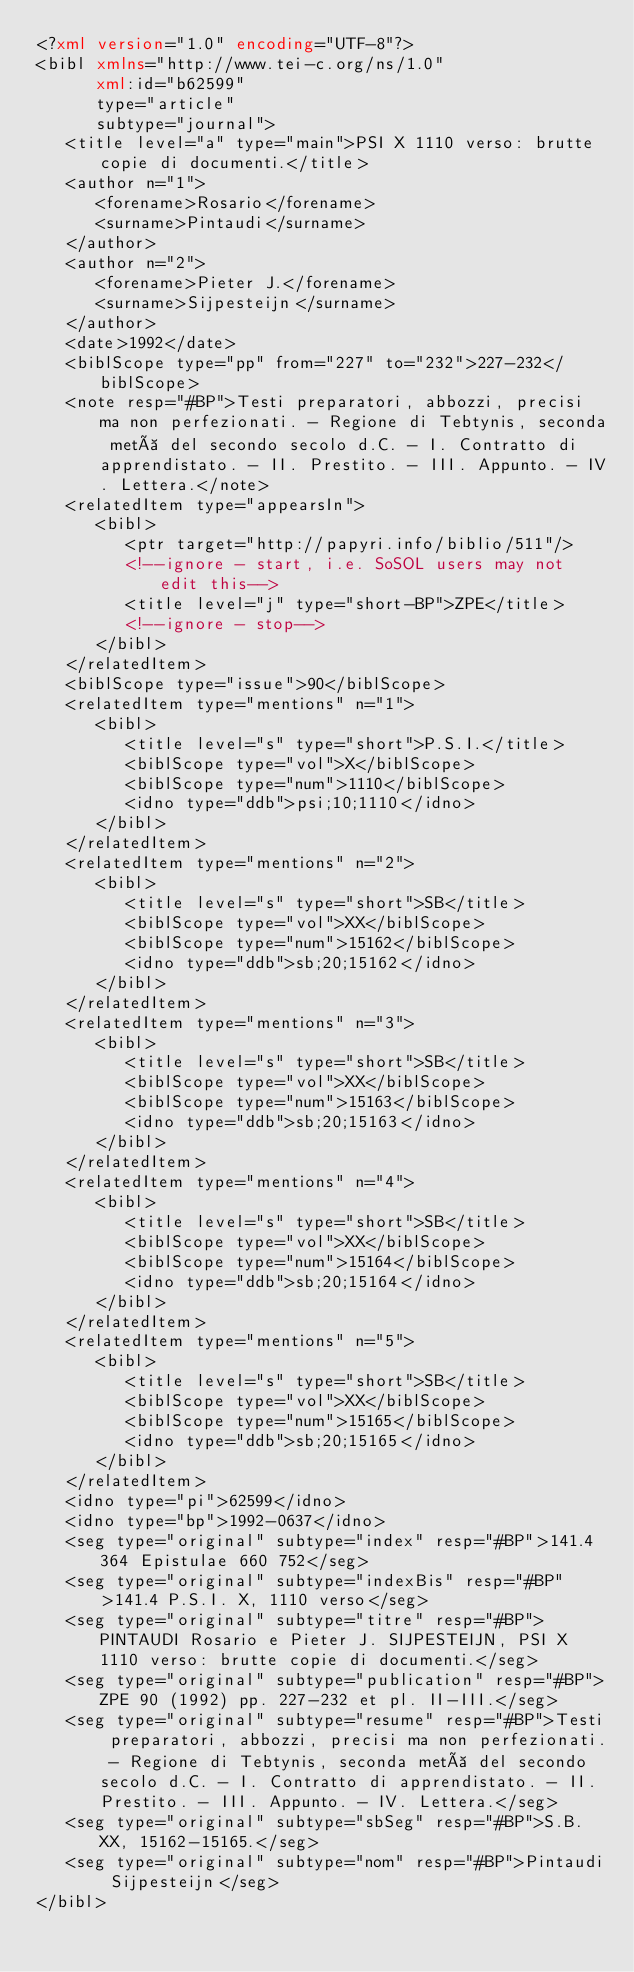<code> <loc_0><loc_0><loc_500><loc_500><_XML_><?xml version="1.0" encoding="UTF-8"?>
<bibl xmlns="http://www.tei-c.org/ns/1.0"
      xml:id="b62599"
      type="article"
      subtype="journal">
   <title level="a" type="main">PSI X 1110 verso: brutte copie di documenti.</title>
   <author n="1">
      <forename>Rosario</forename>
      <surname>Pintaudi</surname>
   </author>
   <author n="2">
      <forename>Pieter J.</forename>
      <surname>Sijpesteijn</surname>
   </author>
   <date>1992</date>
   <biblScope type="pp" from="227" to="232">227-232</biblScope>
   <note resp="#BP">Testi preparatori, abbozzi, precisi ma non perfezionati. - Regione di Tebtynis, seconda metà del secondo secolo d.C. - I. Contratto di apprendistato. - II. Prestito. - III. Appunto. - IV. Lettera.</note>
   <relatedItem type="appearsIn">
      <bibl>
         <ptr target="http://papyri.info/biblio/511"/>
         <!--ignore - start, i.e. SoSOL users may not edit this-->
         <title level="j" type="short-BP">ZPE</title>
         <!--ignore - stop-->
      </bibl>
   </relatedItem>
   <biblScope type="issue">90</biblScope>
   <relatedItem type="mentions" n="1">
      <bibl>
         <title level="s" type="short">P.S.I.</title>
         <biblScope type="vol">X</biblScope>
         <biblScope type="num">1110</biblScope>
         <idno type="ddb">psi;10;1110</idno>
      </bibl>
   </relatedItem>
   <relatedItem type="mentions" n="2">
      <bibl>
         <title level="s" type="short">SB</title>
         <biblScope type="vol">XX</biblScope>
         <biblScope type="num">15162</biblScope>
         <idno type="ddb">sb;20;15162</idno>
      </bibl>
   </relatedItem>
   <relatedItem type="mentions" n="3">
      <bibl>
         <title level="s" type="short">SB</title>
         <biblScope type="vol">XX</biblScope>
         <biblScope type="num">15163</biblScope>
         <idno type="ddb">sb;20;15163</idno>
      </bibl>
   </relatedItem>
   <relatedItem type="mentions" n="4">
      <bibl>
         <title level="s" type="short">SB</title>
         <biblScope type="vol">XX</biblScope>
         <biblScope type="num">15164</biblScope>
         <idno type="ddb">sb;20;15164</idno>
      </bibl>
   </relatedItem>
   <relatedItem type="mentions" n="5">
      <bibl>
         <title level="s" type="short">SB</title>
         <biblScope type="vol">XX</biblScope>
         <biblScope type="num">15165</biblScope>
         <idno type="ddb">sb;20;15165</idno>
      </bibl>
   </relatedItem>
   <idno type="pi">62599</idno>
   <idno type="bp">1992-0637</idno>
   <seg type="original" subtype="index" resp="#BP">141.4 364 Epistulae 660 752</seg>
   <seg type="original" subtype="indexBis" resp="#BP">141.4 P.S.I. X, 1110 verso</seg>
   <seg type="original" subtype="titre" resp="#BP">PINTAUDI Rosario e Pieter J. SIJPESTEIJN, PSI X 1110 verso: brutte copie di documenti.</seg>
   <seg type="original" subtype="publication" resp="#BP">ZPE 90 (1992) pp. 227-232 et pl. II-III.</seg>
   <seg type="original" subtype="resume" resp="#BP">Testi preparatori, abbozzi, precisi ma non perfezionati. - Regione di Tebtynis, seconda metà del secondo secolo d.C. - I. Contratto di apprendistato. - II. Prestito. - III. Appunto. - IV. Lettera.</seg>
   <seg type="original" subtype="sbSeg" resp="#BP">S.B. XX, 15162-15165.</seg>
   <seg type="original" subtype="nom" resp="#BP">Pintaudi Sijpesteijn</seg>
</bibl>
</code> 